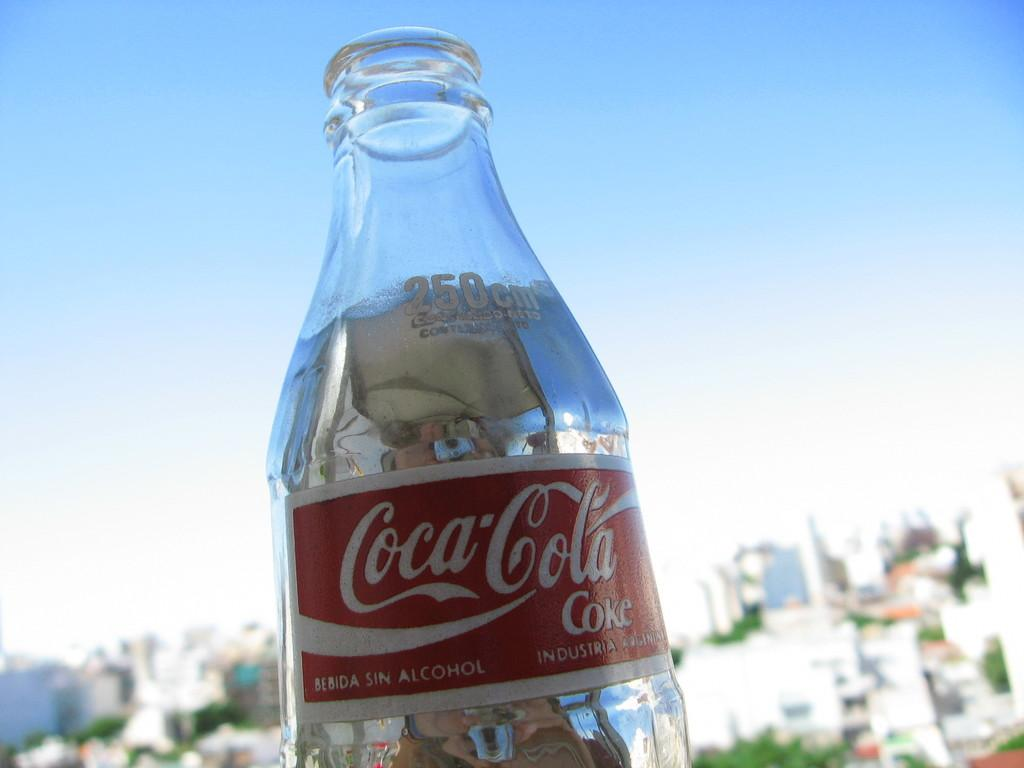What type of beverage bottle is visible in the image? There is a Coca Cola bottle in the image. What colors are used for the writing on the bottle? The writing on the bottle is in red and white colors. How many houses can be seen in the image? There are no houses present in the image; it only features a Coca Cola bottle. What type of pain is being experienced by the bottle in the image? The bottle is an inanimate object and cannot experience pain. 